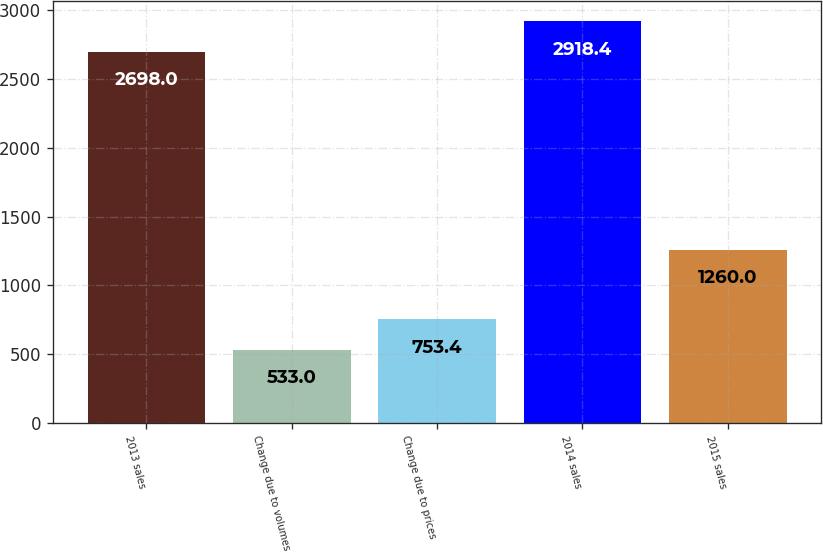Convert chart to OTSL. <chart><loc_0><loc_0><loc_500><loc_500><bar_chart><fcel>2013 sales<fcel>Change due to volumes<fcel>Change due to prices<fcel>2014 sales<fcel>2015 sales<nl><fcel>2698<fcel>533<fcel>753.4<fcel>2918.4<fcel>1260<nl></chart> 